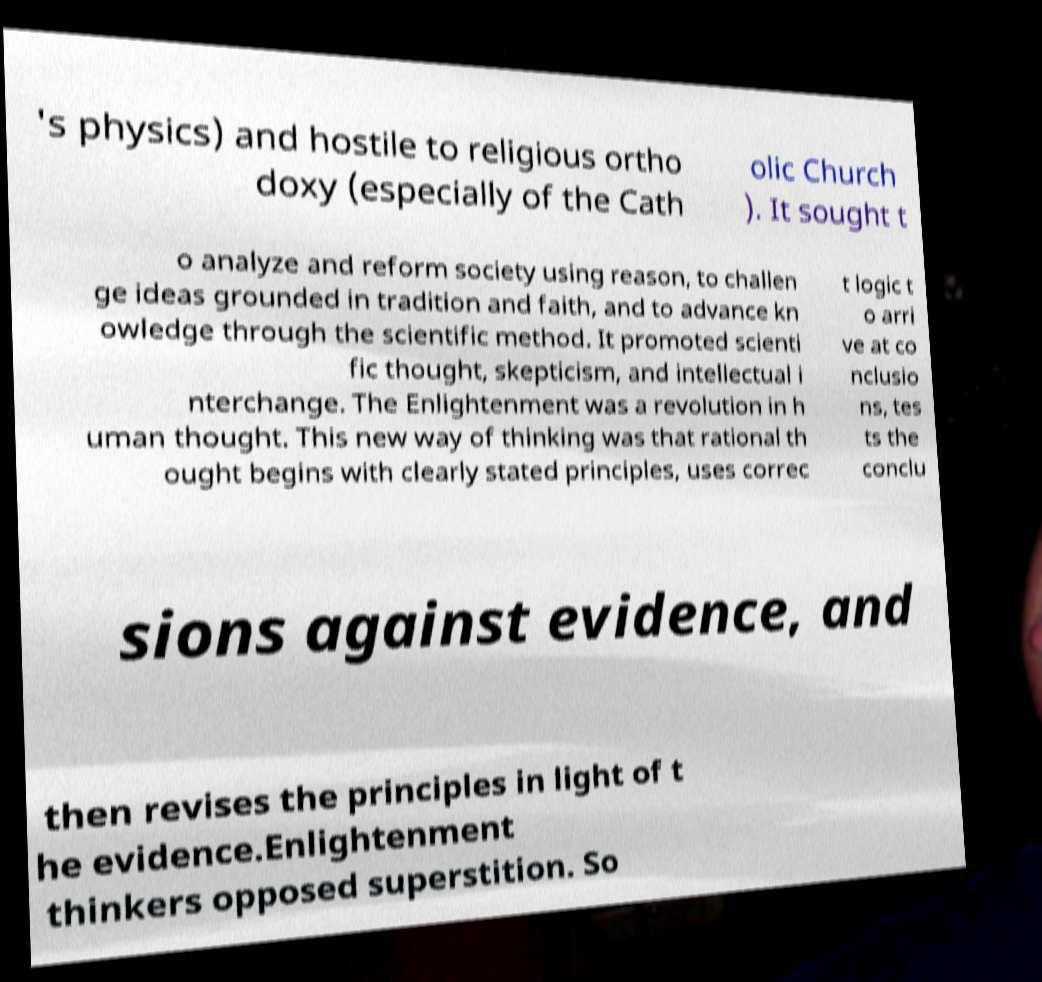Please read and relay the text visible in this image. What does it say? 's physics) and hostile to religious ortho doxy (especially of the Cath olic Church ). It sought t o analyze and reform society using reason, to challen ge ideas grounded in tradition and faith, and to advance kn owledge through the scientific method. It promoted scienti fic thought, skepticism, and intellectual i nterchange. The Enlightenment was a revolution in h uman thought. This new way of thinking was that rational th ought begins with clearly stated principles, uses correc t logic t o arri ve at co nclusio ns, tes ts the conclu sions against evidence, and then revises the principles in light of t he evidence.Enlightenment thinkers opposed superstition. So 